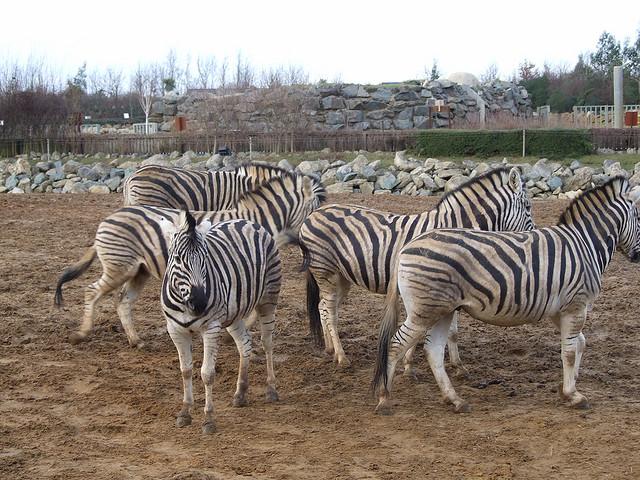How many different types of animals are in the image?
Write a very short answer. 1. What are the zebras standing on?
Answer briefly. Dirt. What animals are these?
Answer briefly. Zebras. How many zebras can you see?
Concise answer only. 5. 